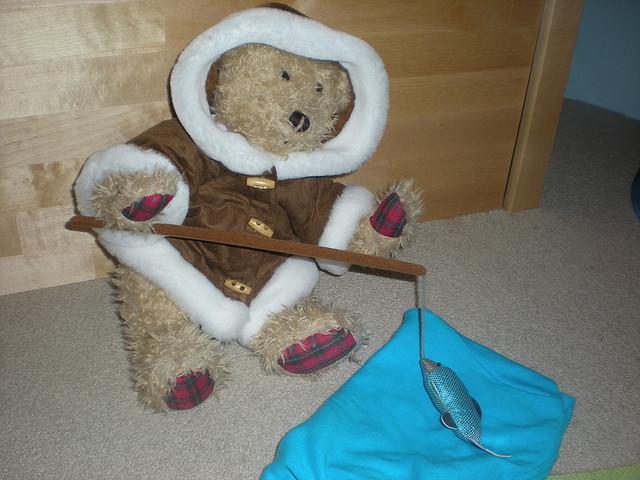What is the bear holding?
Answer briefly. Fishing pole. What color shirt is the bear wearing?
Answer briefly. Brown. What color is the bears jacket?
Short answer required. Brown. What shapes are in the background?
Quick response, please. Rectangles. Is there a cat toy in the photo?
Quick response, please. Yes. What is the floor made of?
Write a very short answer. Carpet. What sport is depicted?
Short answer required. Fishing. 